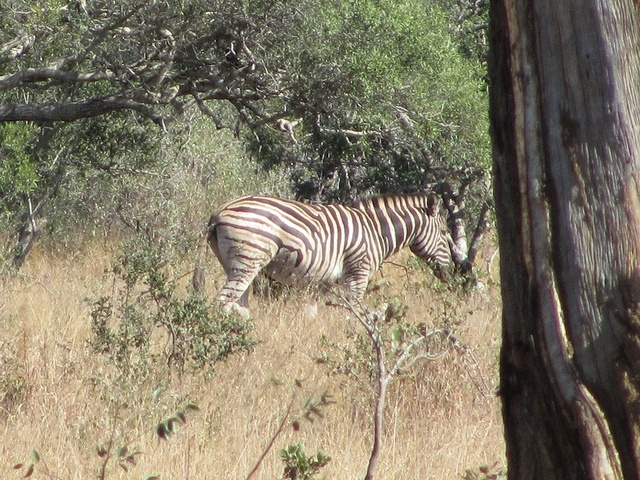Describe the objects in this image and their specific colors. I can see a zebra in gray, ivory, and darkgray tones in this image. 